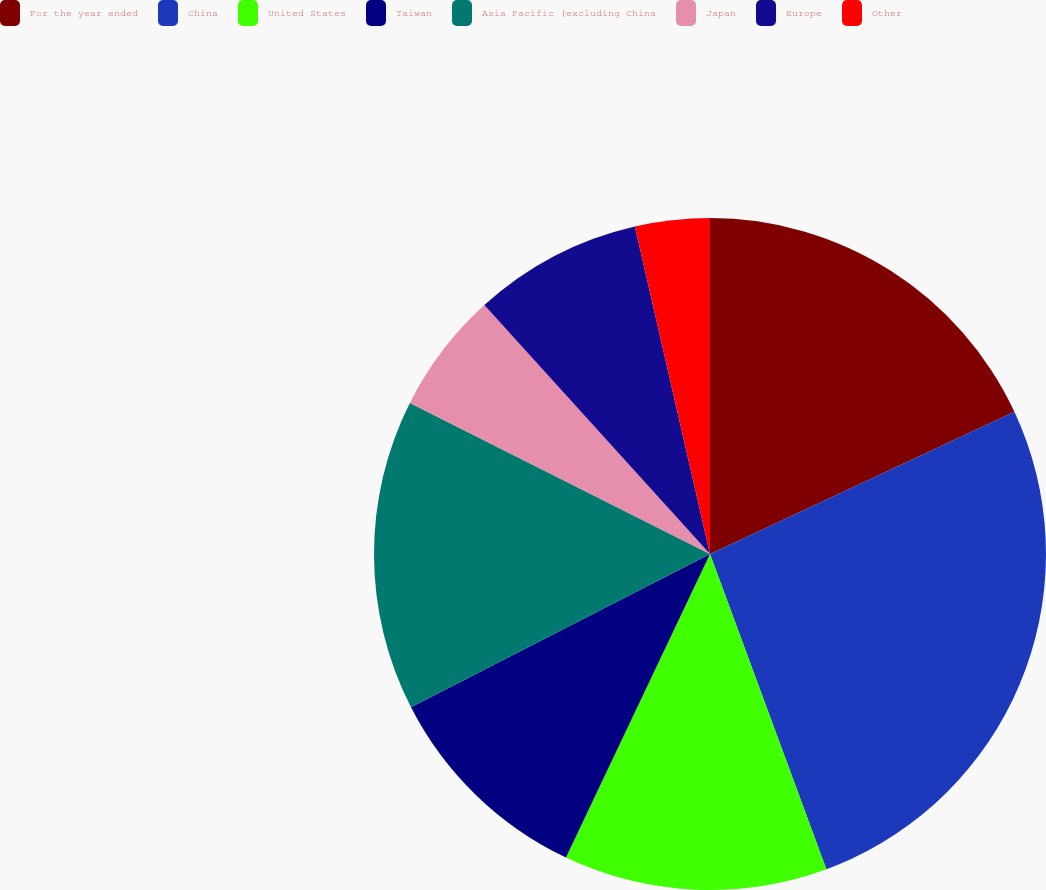Convert chart to OTSL. <chart><loc_0><loc_0><loc_500><loc_500><pie_chart><fcel>For the year ended<fcel>China<fcel>United States<fcel>Taiwan<fcel>Asia Pacific (excluding China<fcel>Japan<fcel>Europe<fcel>Other<nl><fcel>18.04%<fcel>26.33%<fcel>12.68%<fcel>10.41%<fcel>14.96%<fcel>5.86%<fcel>8.13%<fcel>3.59%<nl></chart> 